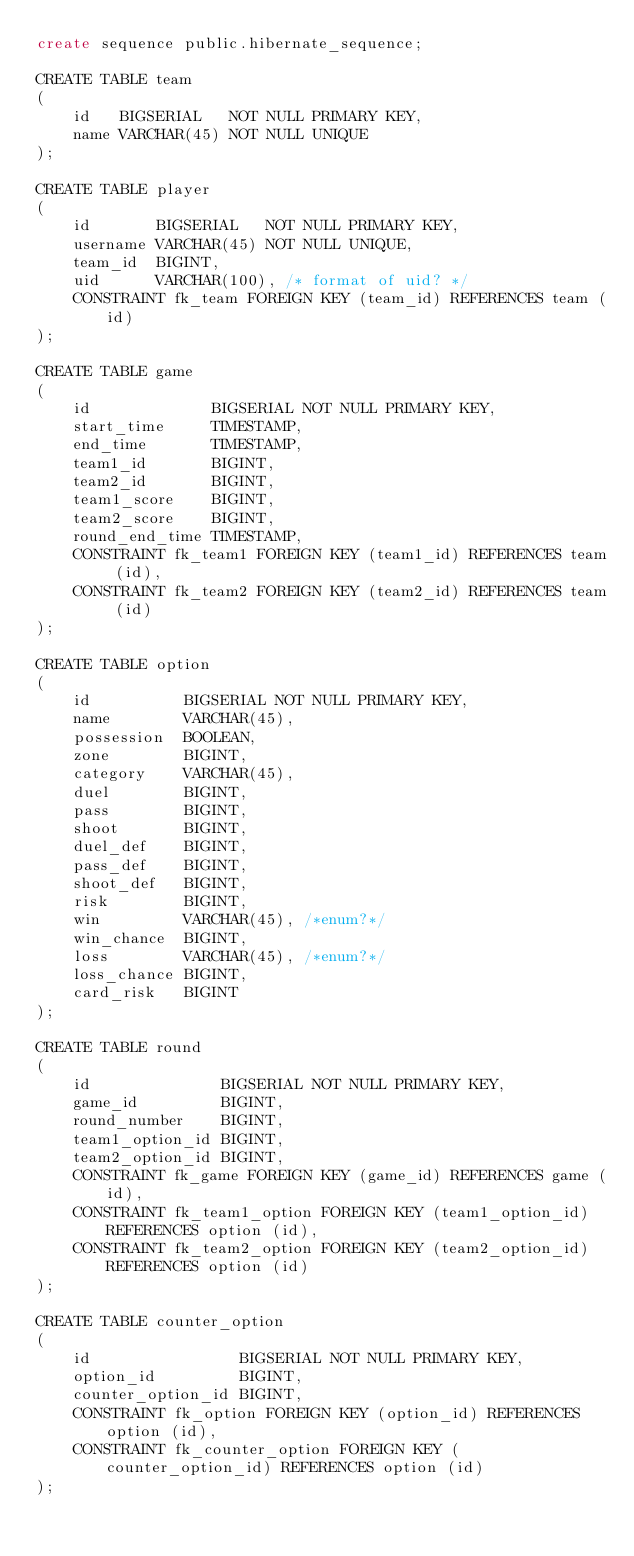<code> <loc_0><loc_0><loc_500><loc_500><_SQL_>create sequence public.hibernate_sequence;

CREATE TABLE team
(
    id   BIGSERIAL   NOT NULL PRIMARY KEY,
    name VARCHAR(45) NOT NULL UNIQUE
);

CREATE TABLE player
(
    id       BIGSERIAL   NOT NULL PRIMARY KEY,
    username VARCHAR(45) NOT NULL UNIQUE,
    team_id  BIGINT,
    uid      VARCHAR(100), /* format of uid? */
    CONSTRAINT fk_team FOREIGN KEY (team_id) REFERENCES team (id)
);

CREATE TABLE game
(
    id             BIGSERIAL NOT NULL PRIMARY KEY,
    start_time     TIMESTAMP,
    end_time       TIMESTAMP,
    team1_id       BIGINT,
    team2_id       BIGINT,
    team1_score    BIGINT,
    team2_score    BIGINT,
    round_end_time TIMESTAMP,
    CONSTRAINT fk_team1 FOREIGN KEY (team1_id) REFERENCES team (id),
    CONSTRAINT fk_team2 FOREIGN KEY (team2_id) REFERENCES team (id)
);

CREATE TABLE option
(
    id          BIGSERIAL NOT NULL PRIMARY KEY,
    name        VARCHAR(45),
    possession  BOOLEAN,
    zone        BIGINT,
    category    VARCHAR(45),
    duel        BIGINT,
    pass        BIGINT,
    shoot       BIGINT,
    duel_def    BIGINT,
    pass_def    BIGINT,
    shoot_def   BIGINT,
    risk        BIGINT,
    win         VARCHAR(45), /*enum?*/
    win_chance  BIGINT,
    loss        VARCHAR(45), /*enum?*/
    loss_chance BIGINT,
    card_risk   BIGINT
);

CREATE TABLE round
(
    id              BIGSERIAL NOT NULL PRIMARY KEY,
    game_id         BIGINT,
    round_number    BIGINT,
    team1_option_id BIGINT,
    team2_option_id BIGINT,
    CONSTRAINT fk_game FOREIGN KEY (game_id) REFERENCES game (id),
    CONSTRAINT fk_team1_option FOREIGN KEY (team1_option_id) REFERENCES option (id),
    CONSTRAINT fk_team2_option FOREIGN KEY (team2_option_id) REFERENCES option (id)
);

CREATE TABLE counter_option
(
    id                BIGSERIAL NOT NULL PRIMARY KEY,
    option_id         BIGINT,
    counter_option_id BIGINT,
    CONSTRAINT fk_option FOREIGN KEY (option_id) REFERENCES option (id),
    CONSTRAINT fk_counter_option FOREIGN KEY (counter_option_id) REFERENCES option (id)
);</code> 